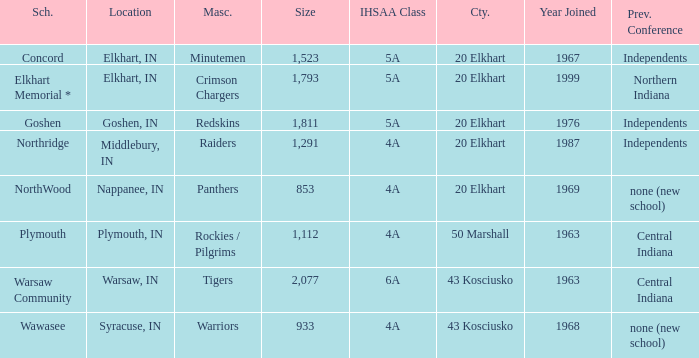Could you help me parse every detail presented in this table? {'header': ['Sch.', 'Location', 'Masc.', 'Size', 'IHSAA Class', 'Cty.', 'Year Joined', 'Prev. Conference'], 'rows': [['Concord', 'Elkhart, IN', 'Minutemen', '1,523', '5A', '20 Elkhart', '1967', 'Independents'], ['Elkhart Memorial *', 'Elkhart, IN', 'Crimson Chargers', '1,793', '5A', '20 Elkhart', '1999', 'Northern Indiana'], ['Goshen', 'Goshen, IN', 'Redskins', '1,811', '5A', '20 Elkhart', '1976', 'Independents'], ['Northridge', 'Middlebury, IN', 'Raiders', '1,291', '4A', '20 Elkhart', '1987', 'Independents'], ['NorthWood', 'Nappanee, IN', 'Panthers', '853', '4A', '20 Elkhart', '1969', 'none (new school)'], ['Plymouth', 'Plymouth, IN', 'Rockies / Pilgrims', '1,112', '4A', '50 Marshall', '1963', 'Central Indiana'], ['Warsaw Community', 'Warsaw, IN', 'Tigers', '2,077', '6A', '43 Kosciusko', '1963', 'Central Indiana'], ['Wawasee', 'Syracuse, IN', 'Warriors', '933', '4A', '43 Kosciusko', '1968', 'none (new school)']]} What country joined before 1976, with IHSSA class of 5a, and a size larger than 1,112? 20 Elkhart. 